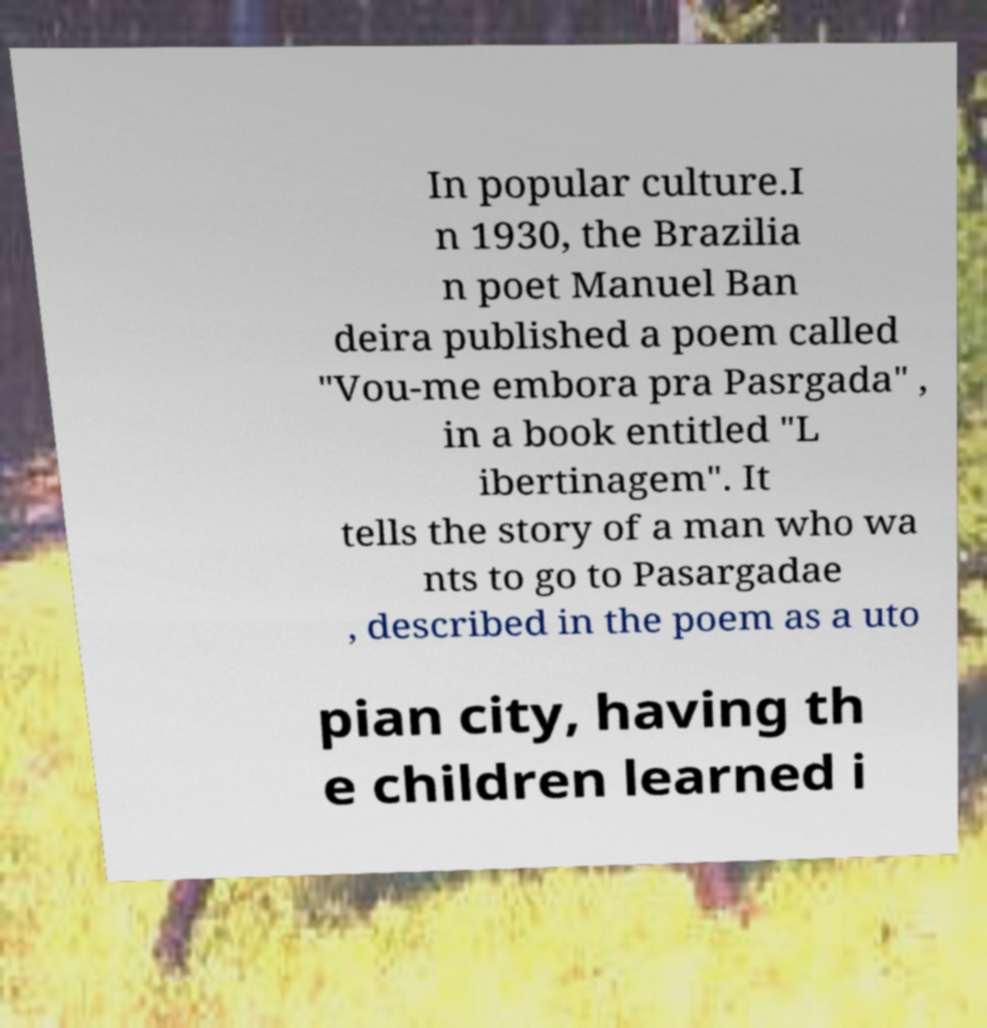I need the written content from this picture converted into text. Can you do that? In popular culture.I n 1930, the Brazilia n poet Manuel Ban deira published a poem called "Vou-me embora pra Pasrgada" , in a book entitled "L ibertinagem". It tells the story of a man who wa nts to go to Pasargadae , described in the poem as a uto pian city, having th e children learned i 